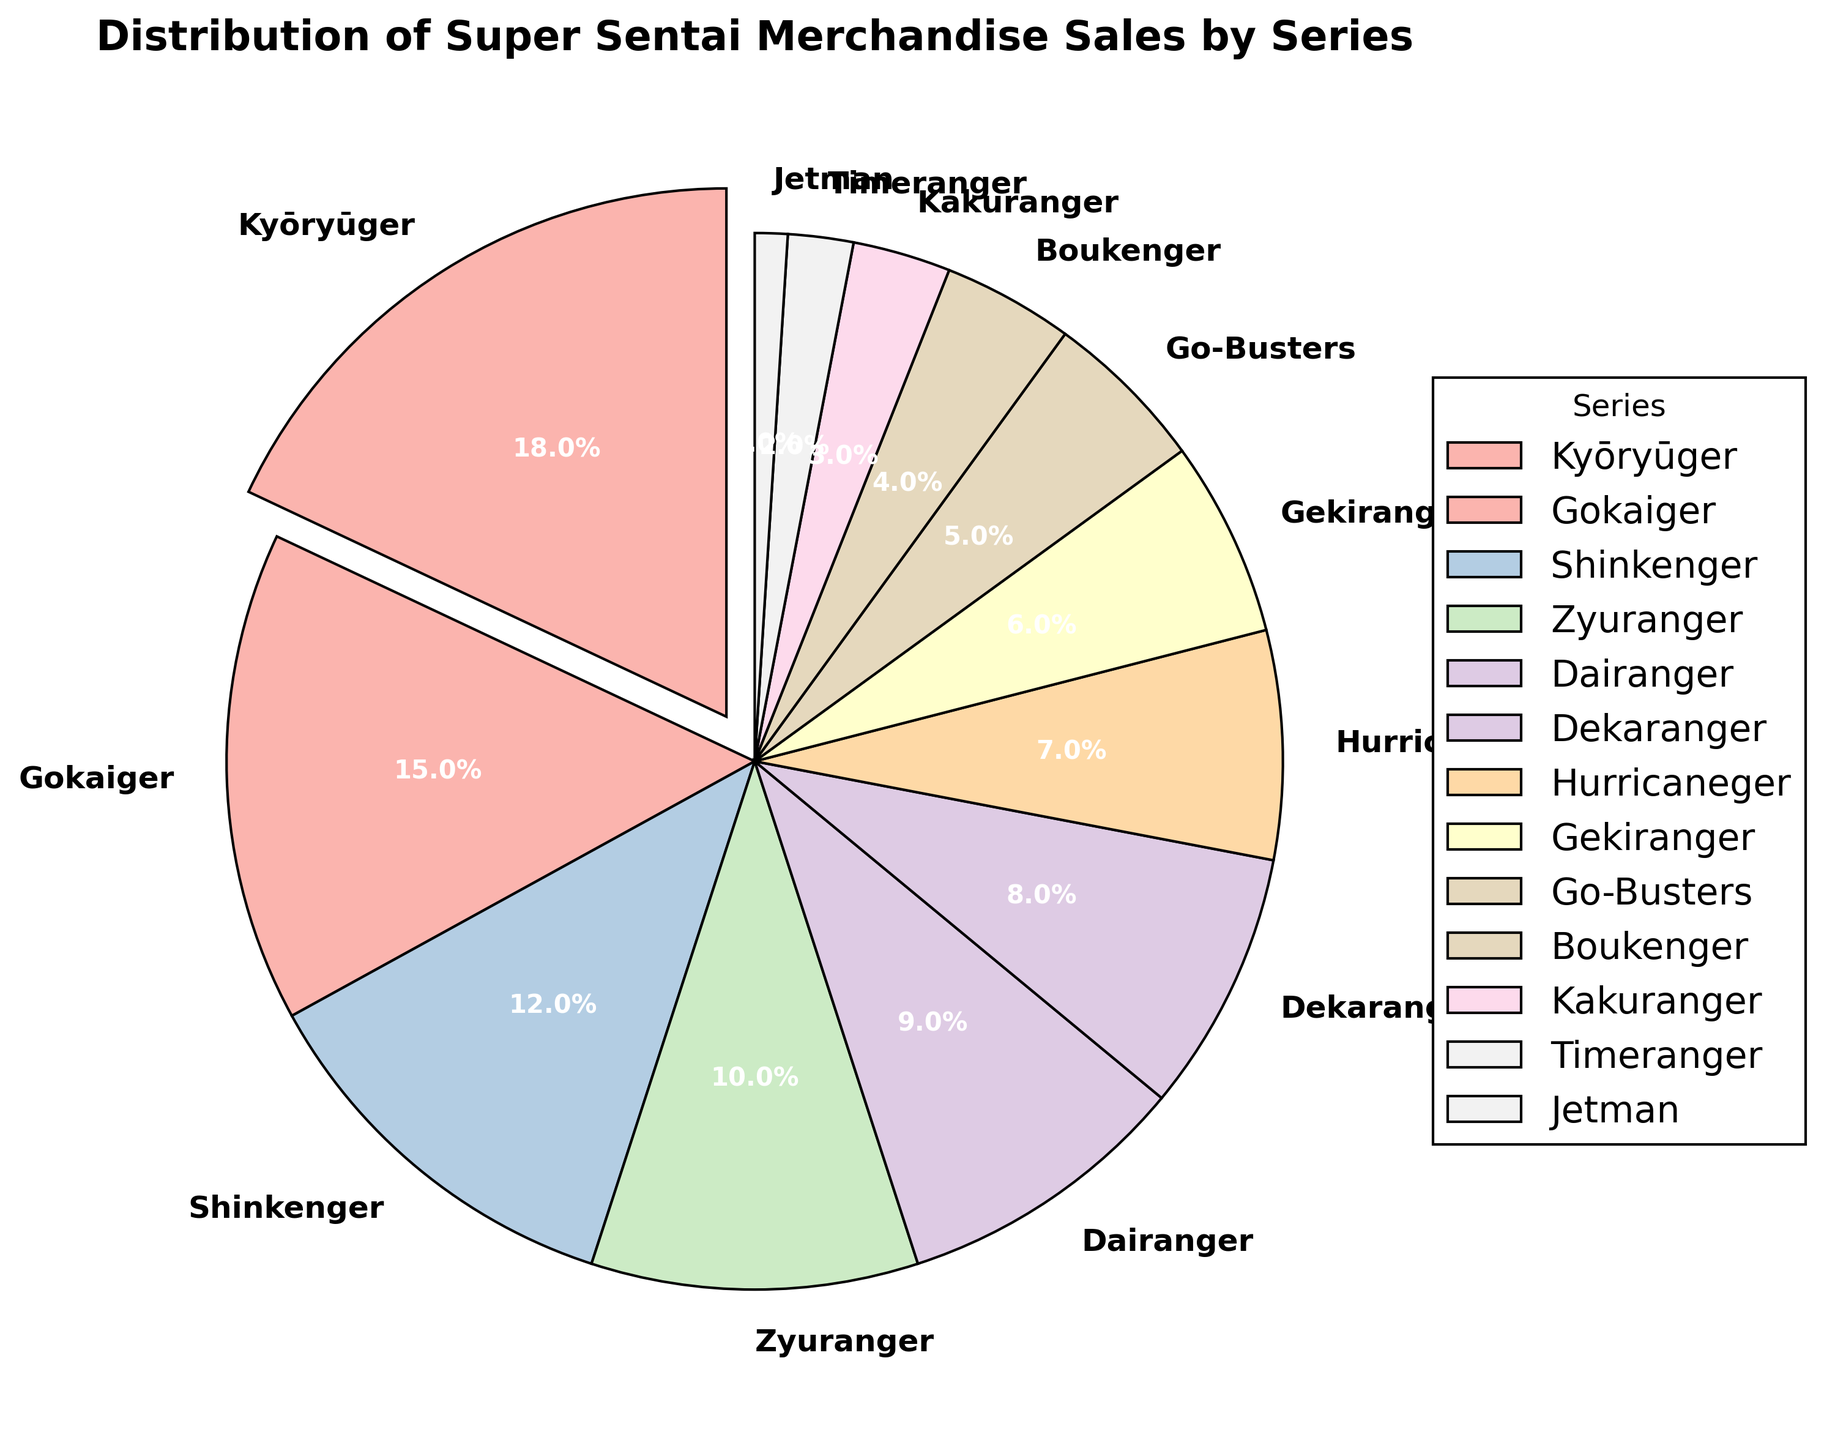Which series has the highest percentage of merchandise sales? The pie chart indicates that Kyōryūger has the largest wedge, highlighted by an extra explosive effect, representing the highest percentage of merchandise sales at 18%.
Answer: Kyōryūger Which two series combined make up less than 5% of the merchandise sales? From the pie chart, Jetman and Timeranger constitute the smallest wedges. Jetman has 1% and Timeranger has 2%, so combined, they make up 3% of the merchandise sales.
Answer: Jetman and Timeranger How much more in percentage does Kyōryūger have compared to Zyuranger? Kyōryūger sales are at 18%, whereas Zyuranger sales are at 10%. The difference between them is 18% - 10% = 8%.
Answer: 8% Which series represents the smallest percentage and how much is it? Looking at the pie chart, the smallest wedge belongs to Jetman, which is labeled with 1%.
Answer: Jetman, 1% If you combined the percentages of Gokaiger and Shinkenger, what would their total be and how would it compare to Kyōryūger? Gokaiger is 15% and Shinkenger is 12%. Combined, they total 15% + 12% = 27%, which is 9% more than Kyōryūger's 18%.
Answer: 27%, 9% more How many series have a percentage of 5% or less? By examining the pie chart, Go-Busters (5%), Boukenger (4%), Kakuranger (3%), Timeranger (2%), and Jetman (1%) fall into this category, so there are 5 series.
Answer: 5 Which two series have the closest percentage of merchandise sales, and what are their respective percentages? Dekaranger and Hurricaneger have almost identical wedges, showing 8% and 7% respectively.
Answer: Dekaranger (8%), Hurricaneger (7%) What is the average percentage of merchandise sales for Dekaranger, Hurricaneger, and Gekiranger? Adding the percentages: Dekaranger (8%) + Hurricaneger (7%) + Gekiranger (6%) = 21%. Dividing by 3, the average is 21% / 3 = 7%.
Answer: 7% Is the percentage of merchandise sales for Shinkenger greater than the total percentage of merchandise sales for Boukenger and Gekiranger combined? Shinkenger is at 12%. Boukenger is 4% and Gekiranger is 6%, so combined they are 4% + 6% = 10%, which is less than Shinkenger's 12%.
Answer: Yes Between Dekaranger and Dairanger, which series has a higher percentage of merchandise sales and by how much? Dekaranger has 8% while Dairanger has 9%. So, Dairanger has 1% more than Dekaranger.
Answer: Dairanger, 1% more 